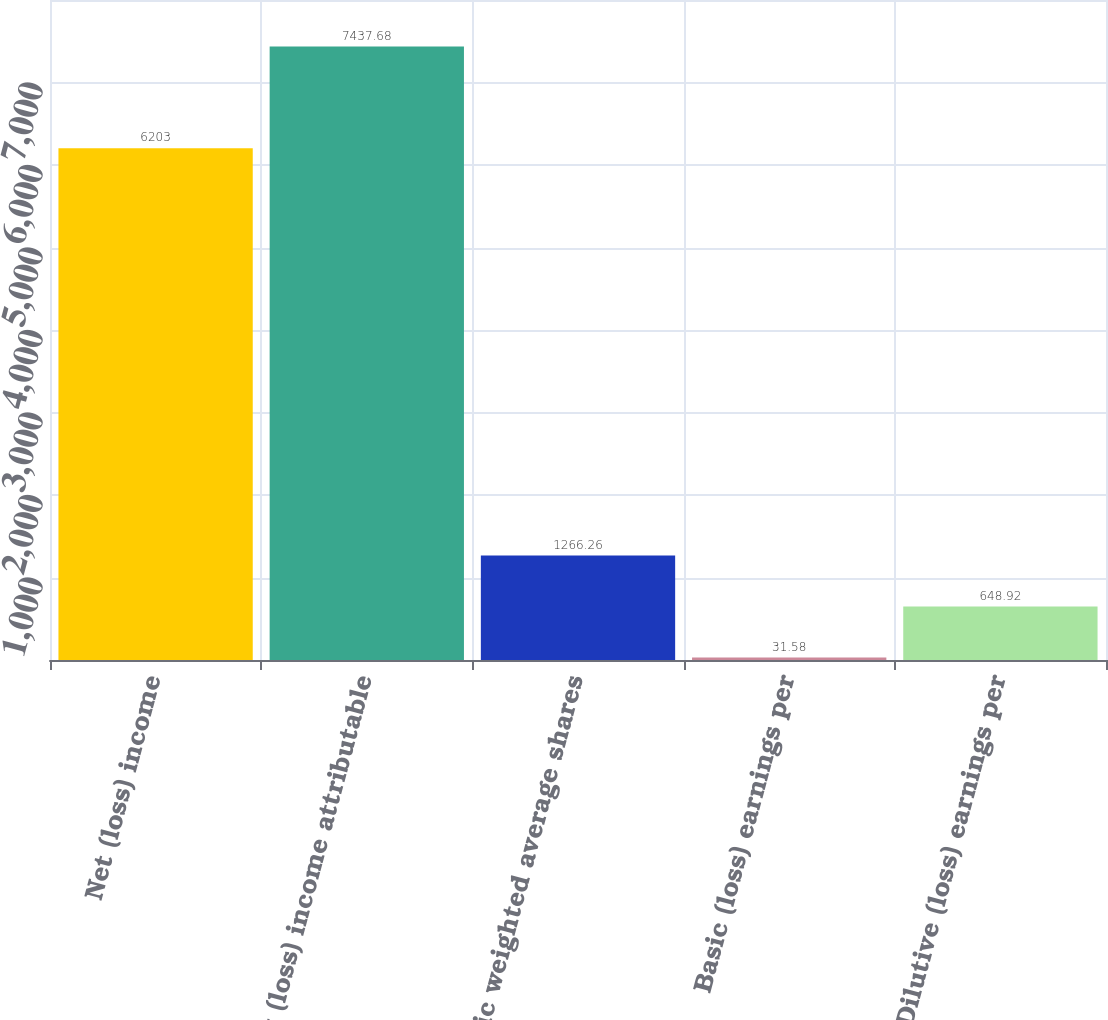<chart> <loc_0><loc_0><loc_500><loc_500><bar_chart><fcel>Net (loss) income<fcel>Net (loss) income attributable<fcel>Basic weighted average shares<fcel>Basic (loss) earnings per<fcel>Dilutive (loss) earnings per<nl><fcel>6203<fcel>7437.68<fcel>1266.26<fcel>31.58<fcel>648.92<nl></chart> 